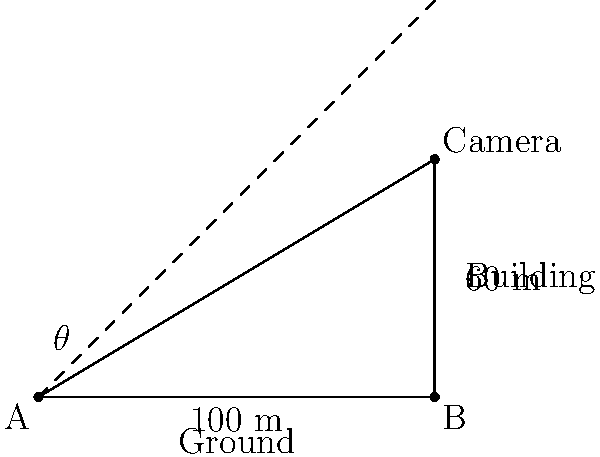A surveillance camera needs to be mounted on top of a 60-meter tall building to monitor an area 100 meters away from the base of the building. What is the angle of elevation (θ) at which the camera should be positioned to effectively cover the target area? To solve this problem, we'll use the tangent function from trigonometry. Here's a step-by-step approach:

1) First, identify the right triangle formed by the building, the ground, and the line of sight from the camera to the target.

2) In this right triangle:
   - The adjacent side is the horizontal distance from the building to the target (100 m)
   - The opposite side is the height of the building (60 m)
   - The angle we're looking for (θ) is the angle of elevation

3) The tangent of an angle in a right triangle is the ratio of the opposite side to the adjacent side:

   $$\tan(\theta) = \frac{\text{opposite}}{\text{adjacent}} = \frac{\text{height}}{\text{distance}}$$

4) Plug in the values:

   $$\tan(\theta) = \frac{60}{100} = 0.6$$

5) To find θ, we need to use the inverse tangent (arctan or tan^(-1)):

   $$\theta = \tan^{-1}(0.6)$$

6) Using a calculator or trigonometric tables:

   $$\theta \approx 30.96^\circ$$

Therefore, the camera should be positioned at an angle of elevation of approximately 30.96° to effectively cover the target area.
Answer: $30.96^\circ$ 